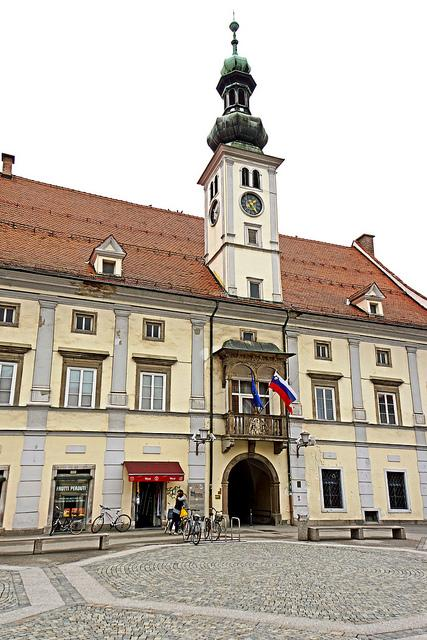What can you use the bike rack for to keep your bike safe?

Choices:
A) selling bike
B) cleaning bike
C) leaning bike
D) bike lock bike lock 